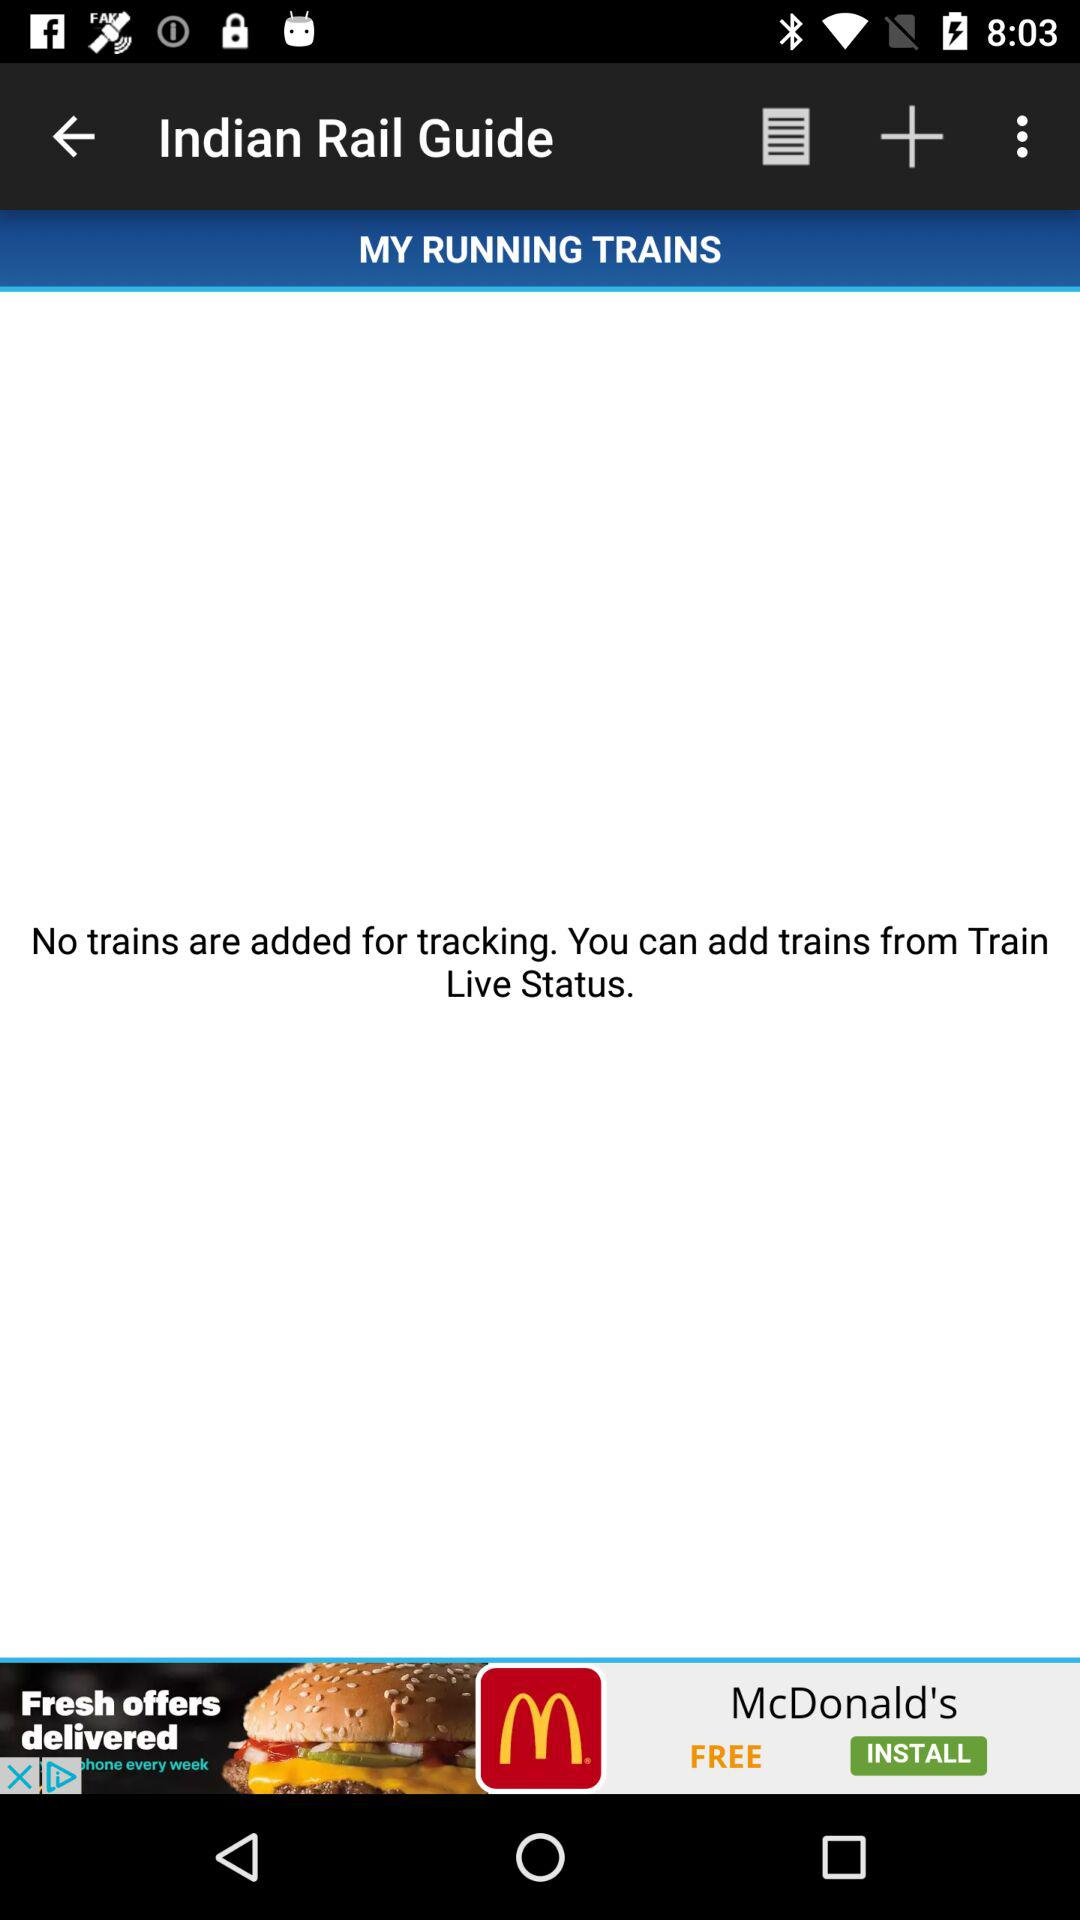How many trains are added for tracking?
Answer the question using a single word or phrase. 0 